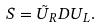Convert formula to latex. <formula><loc_0><loc_0><loc_500><loc_500>S = \tilde { U } _ { R } D U _ { L } .</formula> 